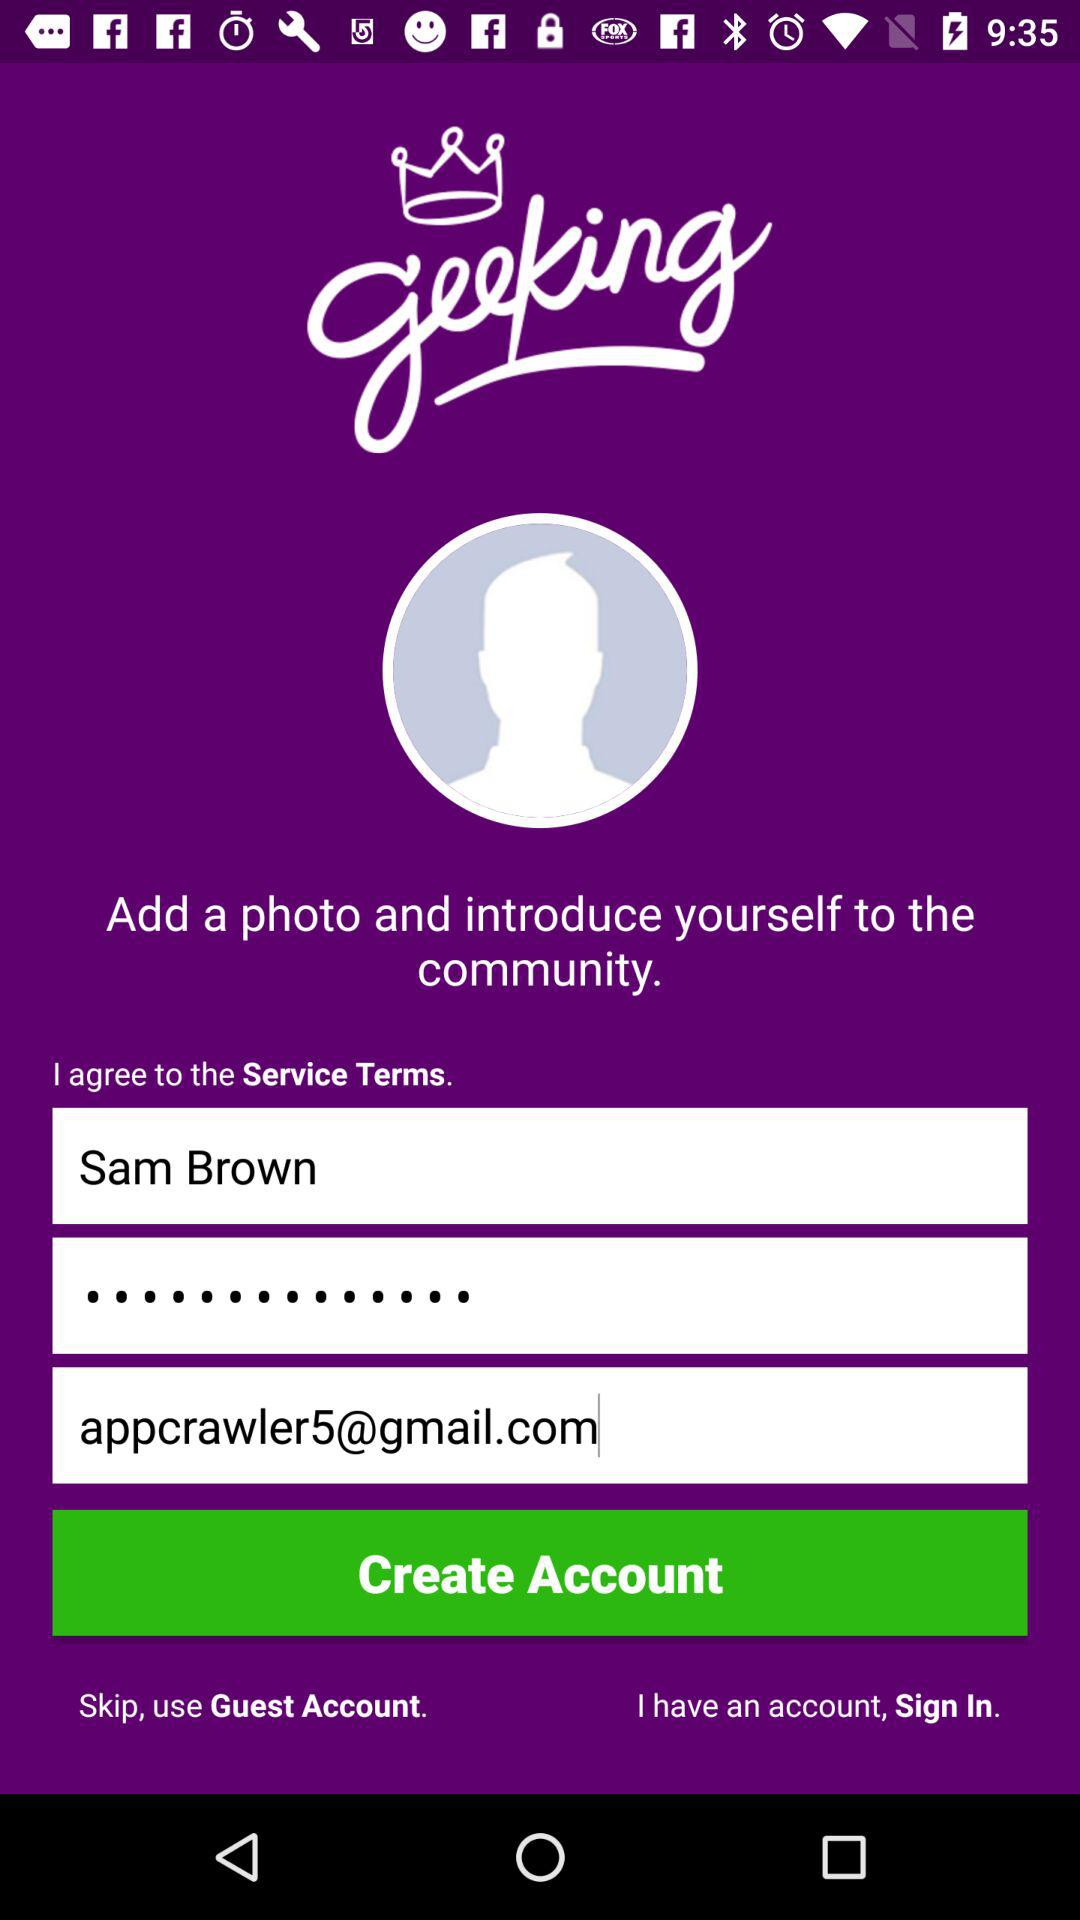How many text inputs are required to create a new account?
Answer the question using a single word or phrase. 3 